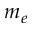Convert formula to latex. <formula><loc_0><loc_0><loc_500><loc_500>m _ { e }</formula> 